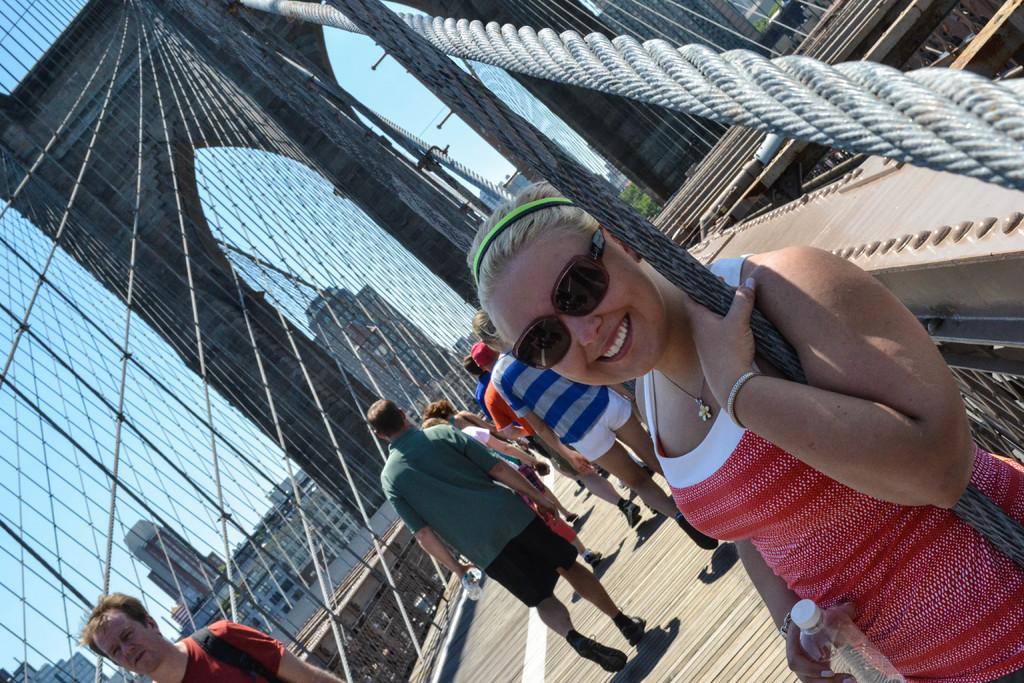Please provide a concise description of this image. In this image we can see a group of people standing on the bridge. In that some people are holding the bottles. We can also see the ropes, poles and a fence. On the backside we can see a group of buildings, a tree and the sky which looks cloudy. 